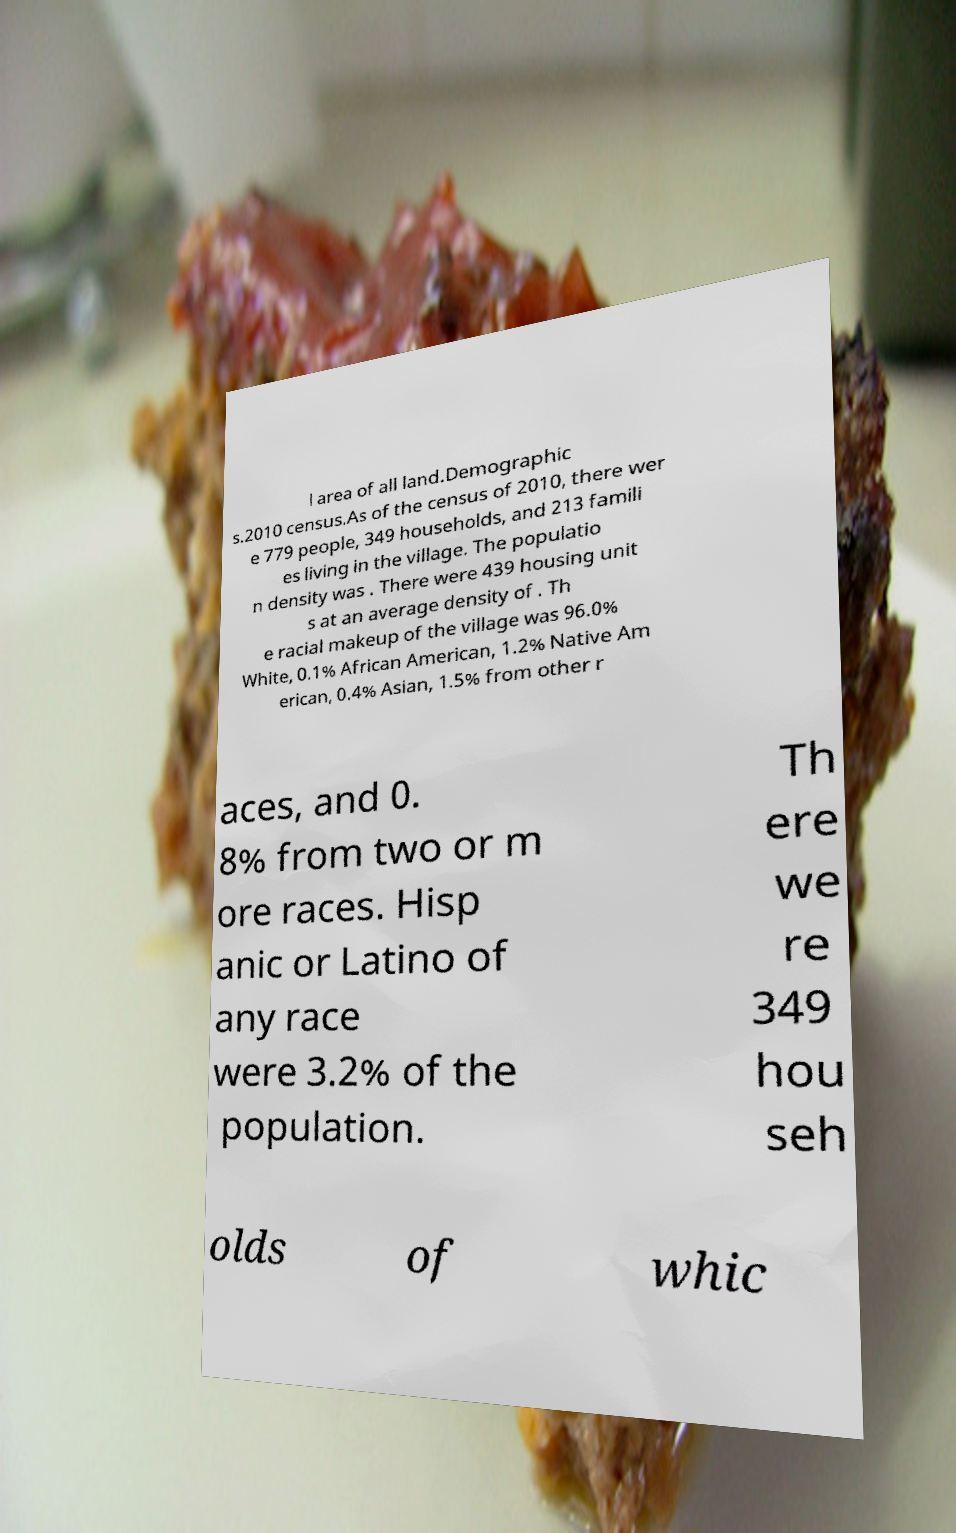For documentation purposes, I need the text within this image transcribed. Could you provide that? l area of all land.Demographic s.2010 census.As of the census of 2010, there wer e 779 people, 349 households, and 213 famili es living in the village. The populatio n density was . There were 439 housing unit s at an average density of . Th e racial makeup of the village was 96.0% White, 0.1% African American, 1.2% Native Am erican, 0.4% Asian, 1.5% from other r aces, and 0. 8% from two or m ore races. Hisp anic or Latino of any race were 3.2% of the population. Th ere we re 349 hou seh olds of whic 